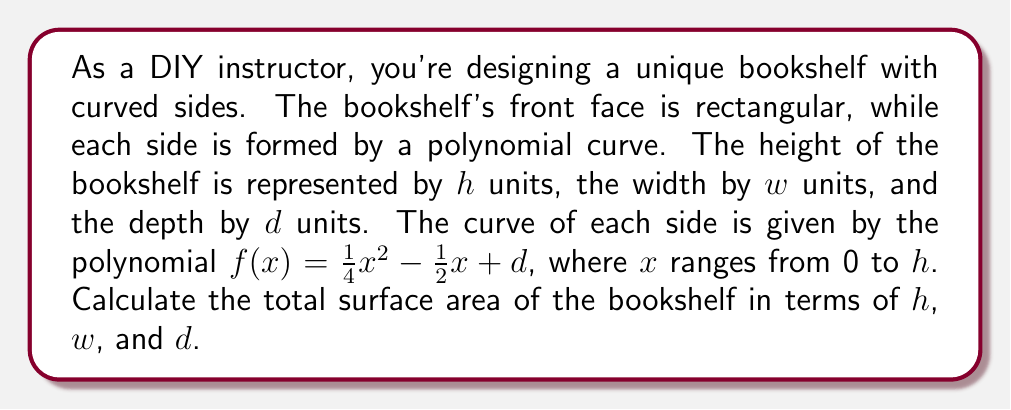Teach me how to tackle this problem. To calculate the total surface area, we need to sum the areas of all faces:

1. Front and back faces (rectangles):
   Area = $2(h \times w) = 2hw$

2. Top and bottom faces (rectangles):
   Area = $2(w \times d) = 2wd$

3. Side faces (curved surfaces):
   To find the area of each side face, we need to use the arc length formula for a polynomial function:
   $$A = \int_0^h \sqrt{1 + [f'(x)]^2} dx$$

   First, let's find $f'(x)$:
   $$f'(x) = \frac{1}{2}x - \frac{1}{2}$$

   Now, we can set up the integral:
   $$A = \int_0^h \sqrt{1 + (\frac{1}{2}x - \frac{1}{2})^2} dx$$

   This integral is complex to solve analytically, so we'll leave it in this form.

   Since there are two side faces, we multiply this by 2.

4. Total surface area:
   $$SA = 2hw + 2wd + 2\int_0^h \sqrt{1 + (\frac{1}{2}x - \frac{1}{2})^2} dx$$
Answer: The total surface area of the bookshelf is:
$$SA = 2hw + 2wd + 2\int_0^h \sqrt{1 + (\frac{1}{2}x - \frac{1}{2})^2} dx$$ 